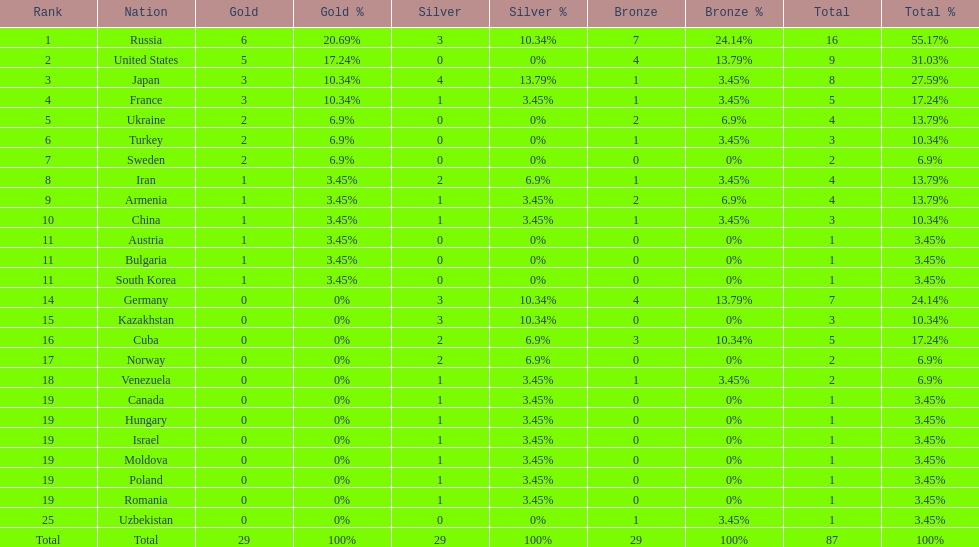Who won more gold medals than the united states? Russia. 